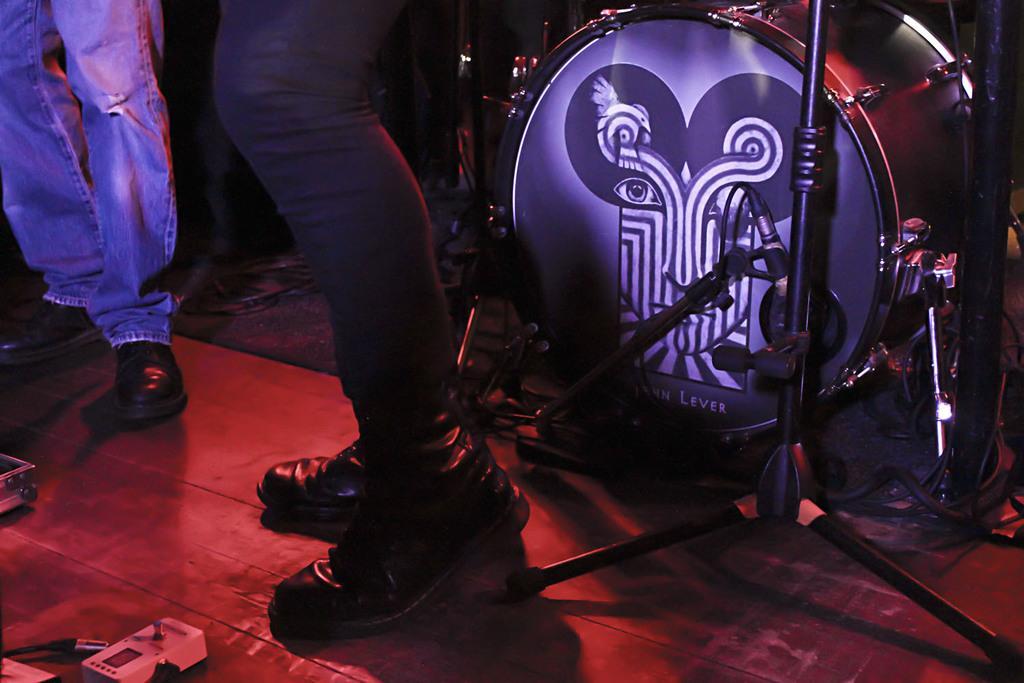Please provide a concise description of this image. In this image there are legs of two persons on the ground. To the right there is a drum on a drum stand. In front of it there is a tripod stand and a microphone. There are cables on the floor. 